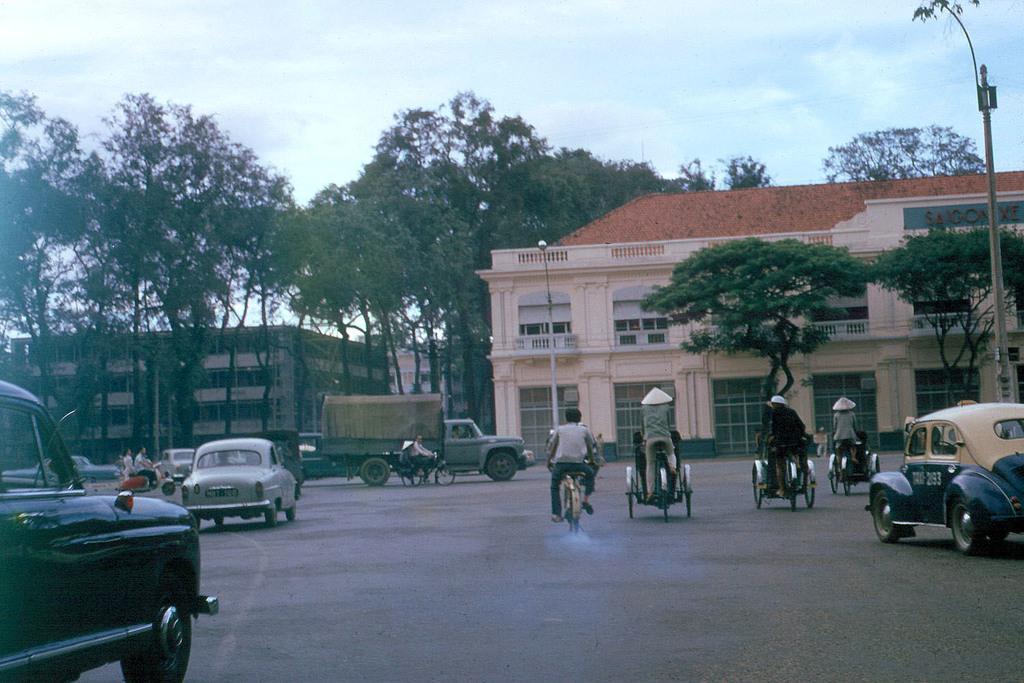Can you describe this image briefly? In the foreground of the picture it is road, on the road there are cars, auto rickshaws and bicycles. In the middle of the picture there are trees, buildings, vehicles, motorbike, cart and other objects. At the top it is sky. On the right there is a pole. 